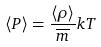Convert formula to latex. <formula><loc_0><loc_0><loc_500><loc_500>\langle P \rangle = \frac { \langle \rho \rangle } { \overline { m } } k T</formula> 